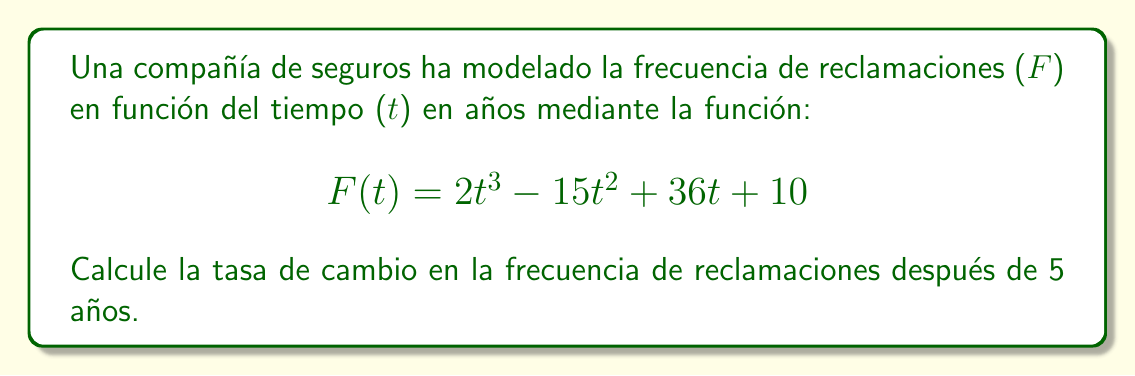What is the answer to this math problem? Para calcular la tasa de cambio en la frecuencia de reclamaciones después de 5 años, necesitamos encontrar la derivada de la función F(t) y luego evaluarla en t = 5.

Paso 1: Calcular la derivada de F(t)
$$F(t) = 2t^3 - 15t^2 + 36t + 10$$
$$F'(t) = 6t^2 - 30t + 36$$

Paso 2: Evaluar F'(t) en t = 5
$$F'(5) = 6(5^2) - 30(5) + 36$$
$$F'(5) = 6(25) - 150 + 36$$
$$F'(5) = 150 - 150 + 36$$
$$F'(5) = 36$$

La tasa de cambio en la frecuencia de reclamaciones después de 5 años es de 36 reclamaciones por año.

Esta información es valiosa para un ejecutivo de seguros interesado en el análisis de riesgos, ya que indica cómo está cambiando la frecuencia de reclamaciones en ese momento específico, lo cual puede influir en las decisiones sobre precios de pólizas y estrategias de gestión de riesgos.
Answer: 36 reclamaciones/año 